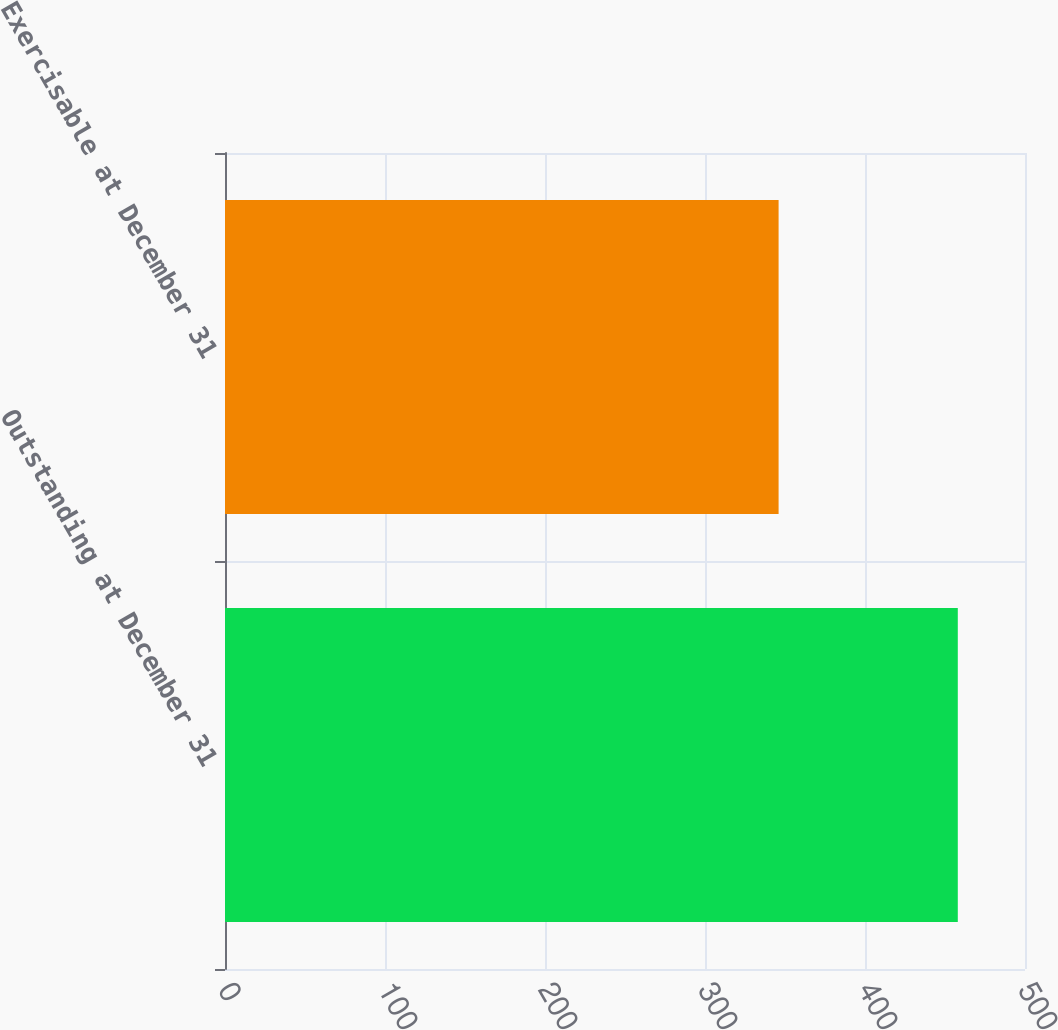<chart> <loc_0><loc_0><loc_500><loc_500><bar_chart><fcel>Outstanding at December 31<fcel>Exercisable at December 31<nl><fcel>458<fcel>346<nl></chart> 